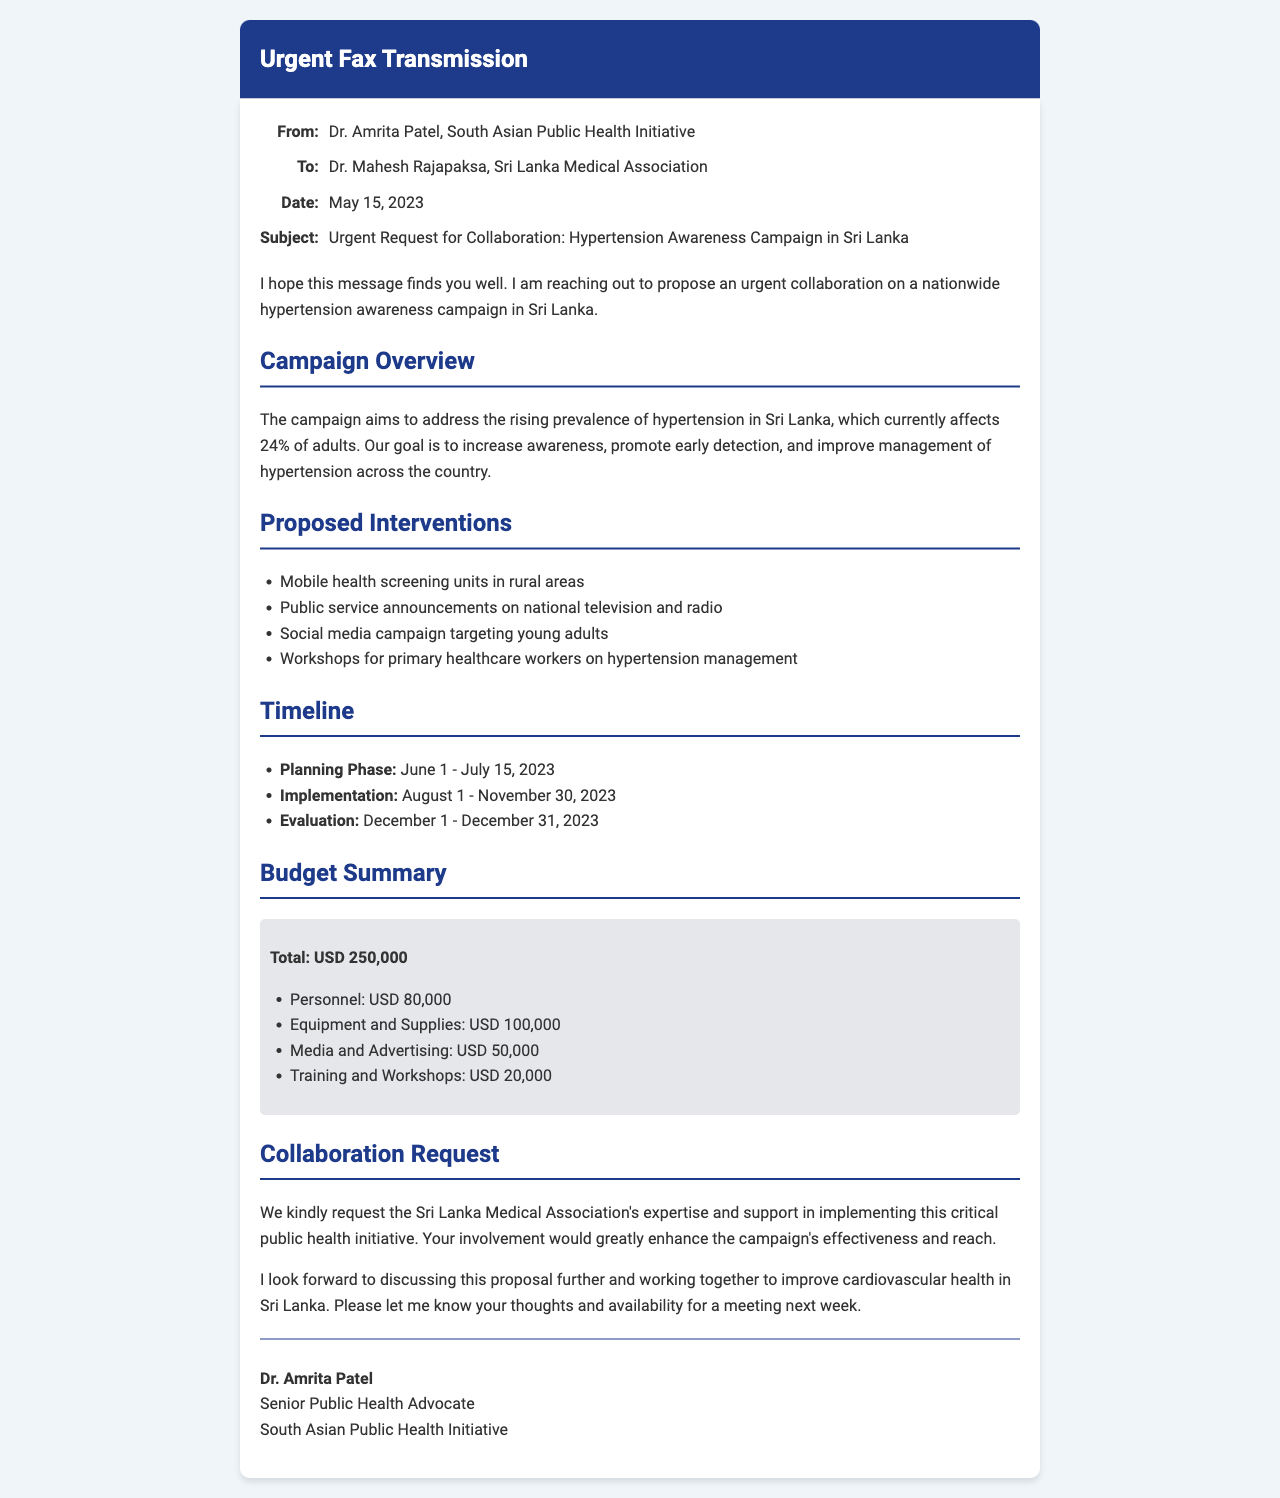what is the percentage of adults affected by hypertension in Sri Lanka? The document states that the current prevalence of hypertension affects 24% of adults in Sri Lanka.
Answer: 24% what is the total proposed budget for the campaign? The document outlines the total proposed budget as USD 250,000 for the hypertension awareness campaign.
Answer: USD 250,000 who is the sender of the fax? The fax identifies Dr. Amrita Patel as the sender from the South Asian Public Health Initiative.
Answer: Dr. Amrita Patel what is the timeframe for the evaluation phase? The evaluation phase is set from December 1 to December 31, 2023, as outlined in the document.
Answer: December 1 - December 31, 2023 which organization is being requested for collaboration? The fax requests collaboration from the Sri Lanka Medical Association for the hypertension awareness campaign.
Answer: Sri Lanka Medical Association how much budget is allocated for media and advertising? The document specifies that USD 50,000 is allocated for media and advertising within the proposed budget.
Answer: USD 50,000 what is one proposed intervention mentioned in the document? The campaign includes mobile health screening units in rural areas as one of its proposed interventions.
Answer: Mobile health screening units in rural areas what are the start and end dates for the planning phase? The planning phase starts on June 1 and ends on July 15, 2023, according to the timeline provided.
Answer: June 1 - July 15, 2023 what is the signature title of Dr. Amrita Patel? Dr. Amrita Patel is identified as a Senior Public Health Advocate in the signature section of the fax.
Answer: Senior Public Health Advocate 